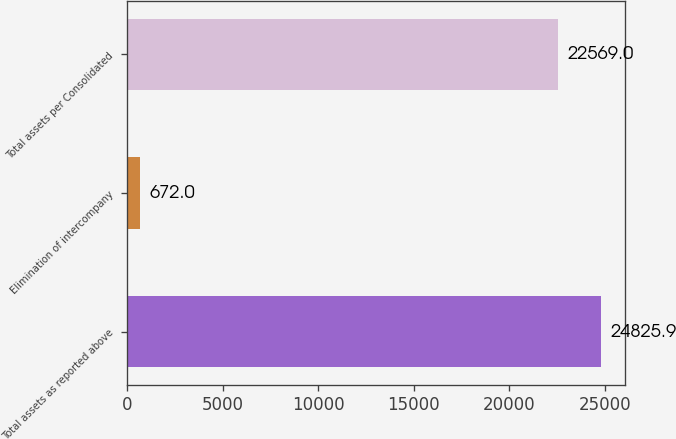Convert chart to OTSL. <chart><loc_0><loc_0><loc_500><loc_500><bar_chart><fcel>Total assets as reported above<fcel>Elimination of intercompany<fcel>Total assets per Consolidated<nl><fcel>24825.9<fcel>672<fcel>22569<nl></chart> 